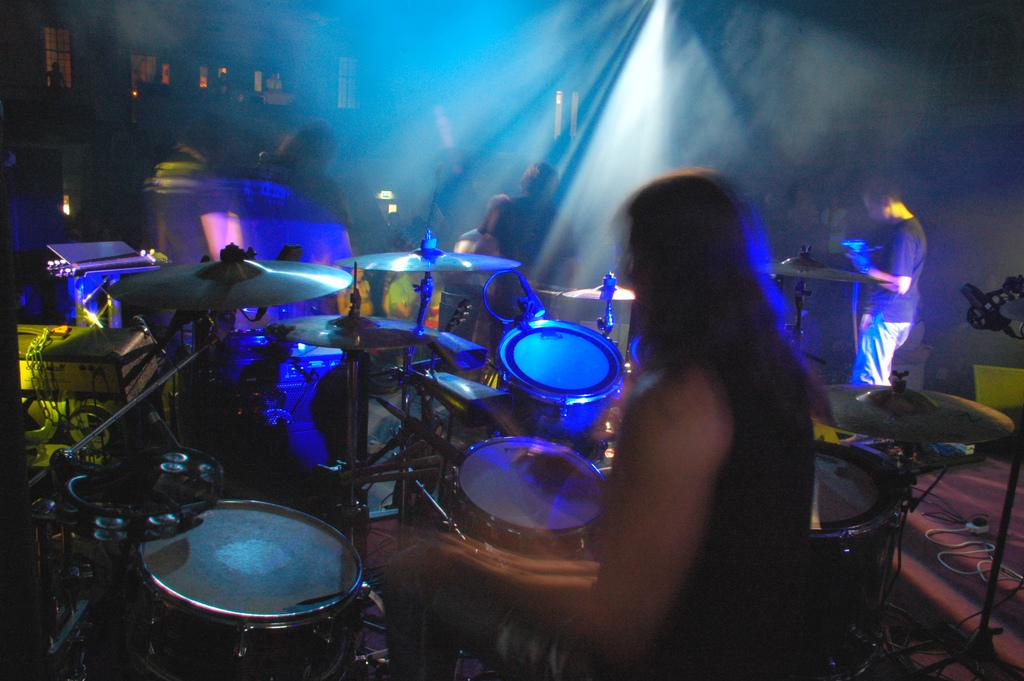Who or what can be seen in the image? There are people in the image. What are the people doing in the image? The people are playing musical instruments in the image. What can be observed about the lighting in the image? The background of the image is dark. Are there any architectural features visible in the image? Yes, there are windows in the image. How many dust particles can be seen floating near the musical instruments in the image? There is no mention of dust particles in the image, so it is not possible to determine their presence or quantity. 